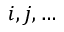<formula> <loc_0><loc_0><loc_500><loc_500>i , j , \dots</formula> 